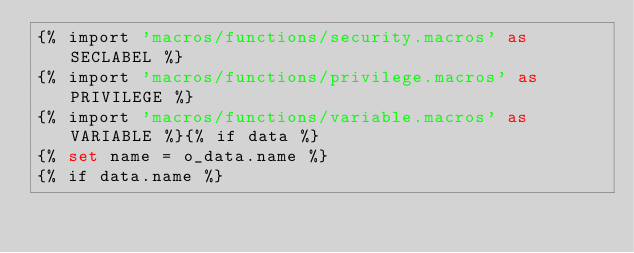Convert code to text. <code><loc_0><loc_0><loc_500><loc_500><_SQL_>{% import 'macros/functions/security.macros' as SECLABEL %}
{% import 'macros/functions/privilege.macros' as PRIVILEGE %}
{% import 'macros/functions/variable.macros' as VARIABLE %}{% if data %}
{% set name = o_data.name %}
{% if data.name %}</code> 